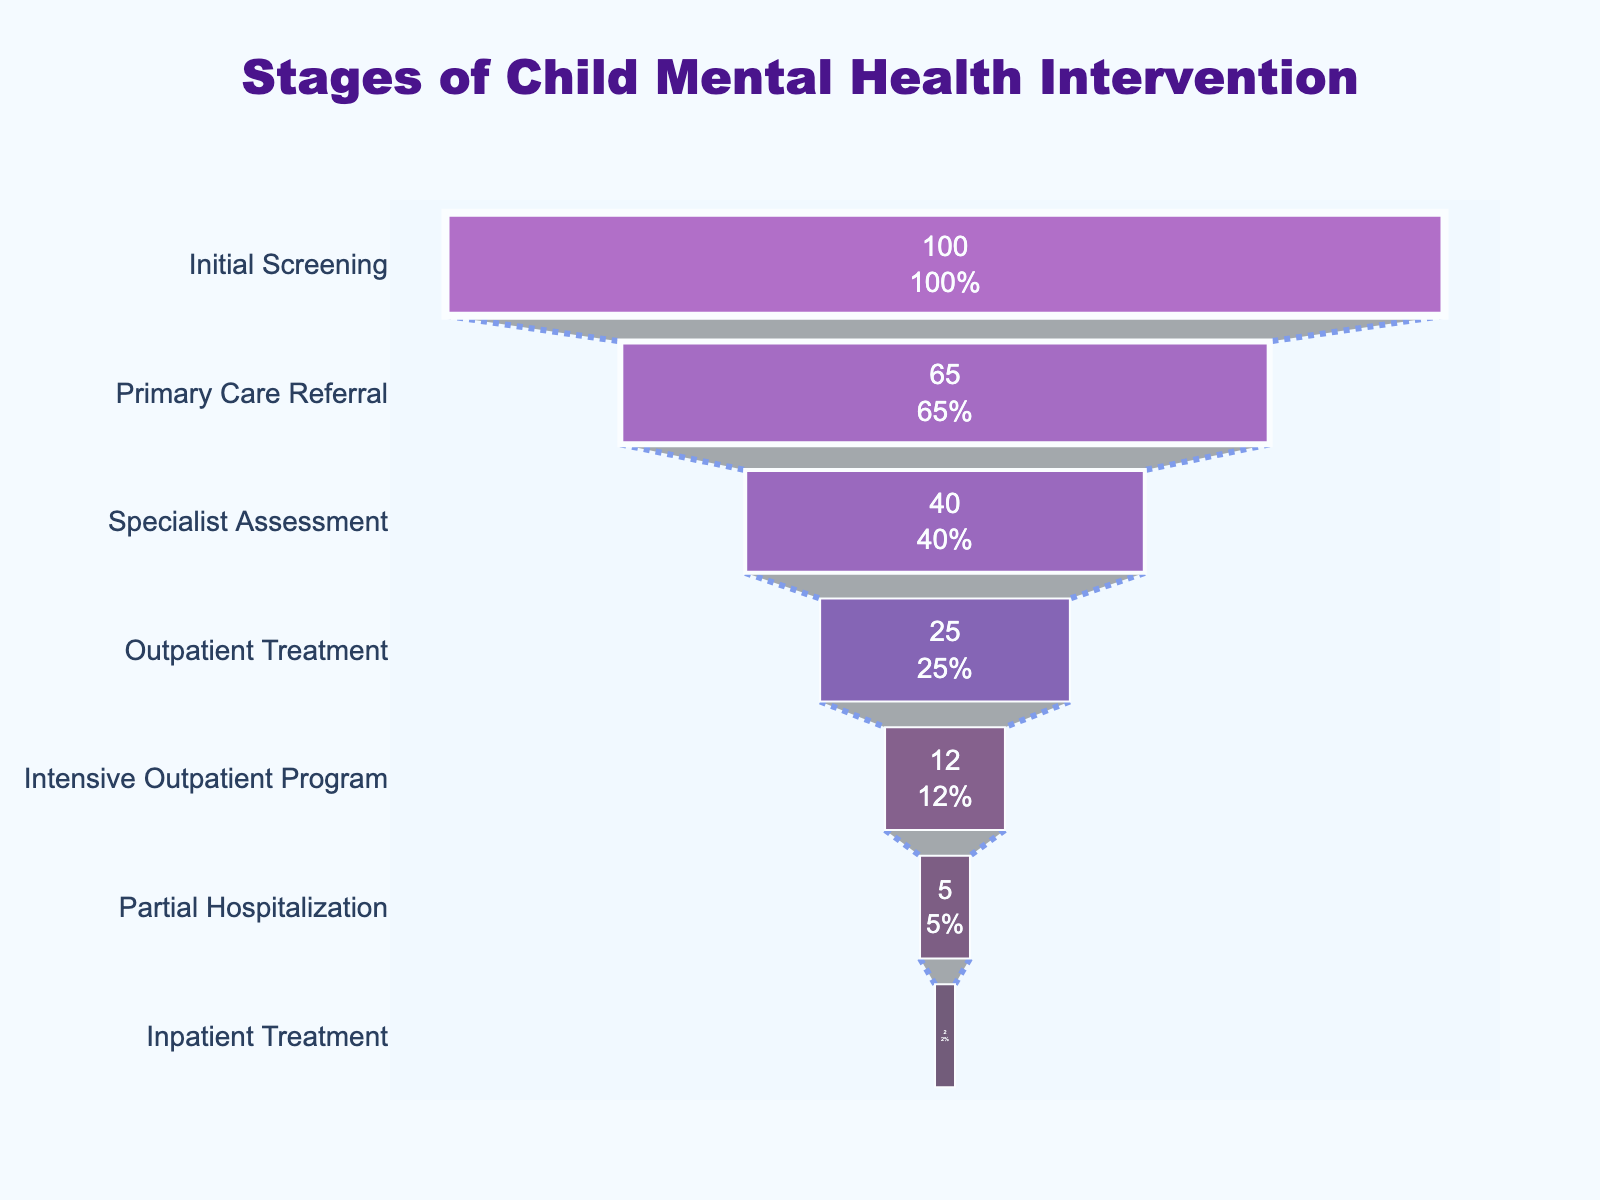What is the title of the Funnel Chart? The title of a chart is usually located at the top and serves as a brief description of what the chart represents. In this case, the title is "Stages of Child Mental Health Intervention" as shown in the plot.
Answer: Stages of Child Mental Health Intervention How many stages are shown in the funnel chart? By looking at the chart, we can count the number of unique stages listed along the y-axis. There are seven distinct stages: Initial Screening, Primary Care Referral, Specialist Assessment, Outpatient Treatment, Intensive Outpatient Program, Partial Hospitalization, Inpatient Treatment.
Answer: Seven Which stage has the highest percentage of cases addressed? The highest percentage corresponds to the widest part of the funnel. Here, the "Initial Screening" stage is at the widest, representing 100%, indicating it has the highest percentage.
Answer: Initial Screening What percentage of cases move from Primary Care Referral to Specialist Assessment? To find the percentage of cases moving from one stage to another, we subtract the percentage of the latter stage from the former. From 65% (Primary Care Referral) to 40% (Specialist Assessment), 65% - 40% = 25%.
Answer: 25% What is the smallest stage by percentage? The smallest part of the funnel corresponds to the narrowest section. In this case, "Inpatient Treatment" is represented by the smallest section, which is 2%.
Answer: Inpatient Treatment How many stages have less than 10% of cases addressed? By scanning through the percentage values, we can identify stages with less than 10%. These are "Partial Hospitalization" (5%) and "Inpatient Treatment" (2%). Thus, there are two stages.
Answer: Two What is the percentage difference between Outpatient Treatment and Intensive Outpatient Program? To find the percentage difference, we subtract the smaller percentage from the larger. "Outpatient Treatment" is 25% and "Intensive Outpatient Program" is 12%. Thus, 25% - 12% = 13%.
Answer: 13% What fraction of cases reach the Partial Hospitalization stage? To determine the fraction, we use the percentage for "Partial Hospitalization," which is 5%. Converting the percentage to a fraction, we get 5/100, which simplifies to 1/20.
Answer: 1/20 Which stage shows the greatest reduction in percentage from the previous stage? We need to look at the biggest drop in percentages between consecutive stages. The reduction from "Primary Care Referral" (65%) to "Specialist Assessment" (40%) is 25%. This is the largest reduction in percentage between stages.
Answer: Primary Care Referral to Specialist Assessment What do the white lines on the funnel sections represent? The white lines vary in width and are separators of the stages in the funnel. Each line helps to visually distinguish between different stages by providing clear demarcations even if the background color gradient is similar.
Answer: Separators 